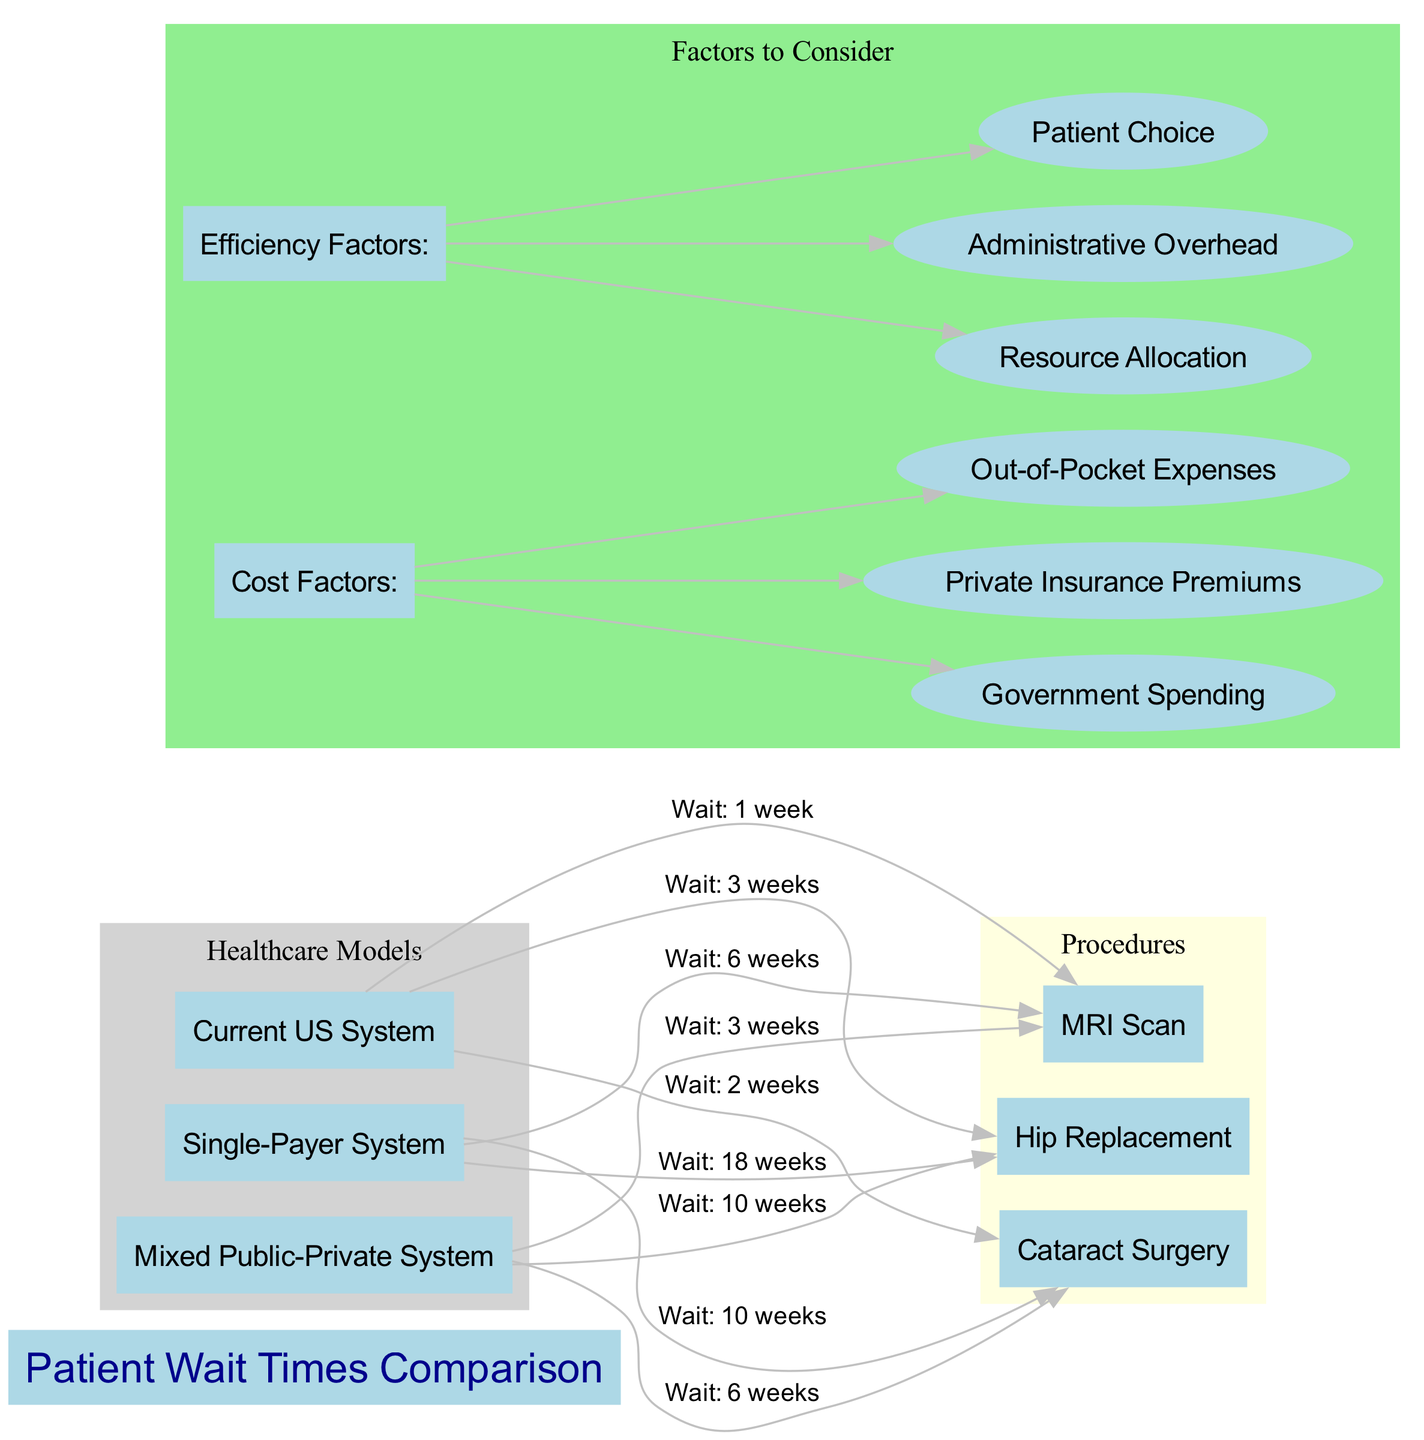What is the wait time for a hip replacement in the Current US System? The diagram specifies that under the Current US System, the wait time for a hip replacement is indicated with an edge connecting "Current US System" and "Hip Replacement", labeled with "Wait: 3 weeks".
Answer: 3 weeks What is the longest wait time listed for cataract surgery? By reviewing the edge connections for cataract surgery in each healthcare model, the longest wait time is found under the Single-Payer System, which shows "Wait: 10 weeks".
Answer: 10 weeks Which healthcare model has the shortest wait time for an MRI scan? The wait times for MRI scans are compared across the three models. The Current US System shows the shortest wait time with "Wait: 1 week".
Answer: Current US System How many total procedures are compared in this diagram? The diagram lists three procedures: Hip Replacement, Cataract Surgery, and MRI Scan. By counting the nodes in the procedure cluster, we confirm there are three procedures.
Answer: 3 Can you list the cost factors considered in this diagram? The diagram includes a subgraph labeled "Cost Factors" which identifies three factors: Government Spending, Private Insurance Premiums, and Out-of-Pocket Expenses.
Answer: Government Spending, Private Insurance Premiums, Out-of-Pocket Expenses What procedure has the longest wait time under the Mixed Public-Private System? The connections indicate that the hip replacement under the Mixed Public-Private System has the longest wait time of "Wait: 10 weeks".
Answer: Hip Replacement Which healthcare model shows an MRI wait time of 3 weeks? The edge labeled "Wait: 3 weeks" connects the Mixed Public-Private System to the MRI Scan, indicating that this model has a wait time of 3 weeks for that procedure.
Answer: Mixed Public-Private System Under which healthcare model is patient choice identified as a factor? The diagram outlines various efficiency factors, including patient choice; it is part of the subgraph labeled "Efficiency Factors", applicable to all healthcare models but explicitly listed under the Mixed Public-Private System context.
Answer: Mixed Public-Private System Which procedure has the shortest wait time across all healthcare models? By comparing the wait times from each model, the MRI Scan under the Current US System has the shortest wait time, which is "Wait: 1 week".
Answer: MRI Scan 